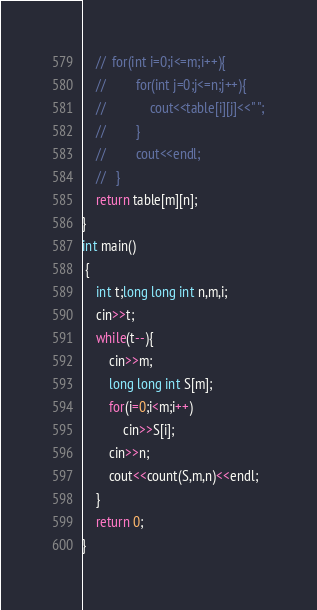Convert code to text. <code><loc_0><loc_0><loc_500><loc_500><_C++_>    //  for(int i=0;i<=m;i++){
    //         for(int j=0;j<=n;j++){
    //             cout<<table[i][j]<<" ";
    //         }
    //         cout<<endl;
    //   } 
    return table[m][n];  
} 
int main()
 {
	int t;long long int n,m,i;
	cin>>t;
	while(t--){
	    cin>>m;
	    long long int S[m];
	    for(i=0;i<m;i++)
	        cin>>S[i];
	    cin>>n;
	    cout<<count(S,m,n)<<endl;
    }
	return 0;
}</code> 